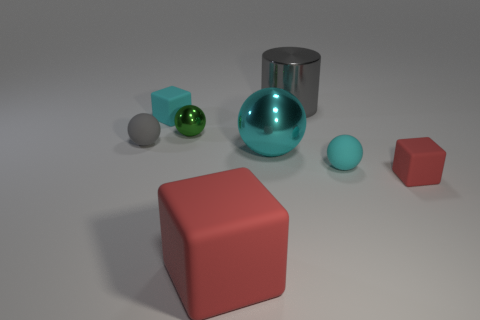Add 1 red rubber things. How many objects exist? 9 Subtract all cubes. How many objects are left? 5 Subtract 1 gray cylinders. How many objects are left? 7 Subtract all cyan objects. Subtract all blue things. How many objects are left? 5 Add 2 large red rubber things. How many large red rubber things are left? 3 Add 4 red things. How many red things exist? 6 